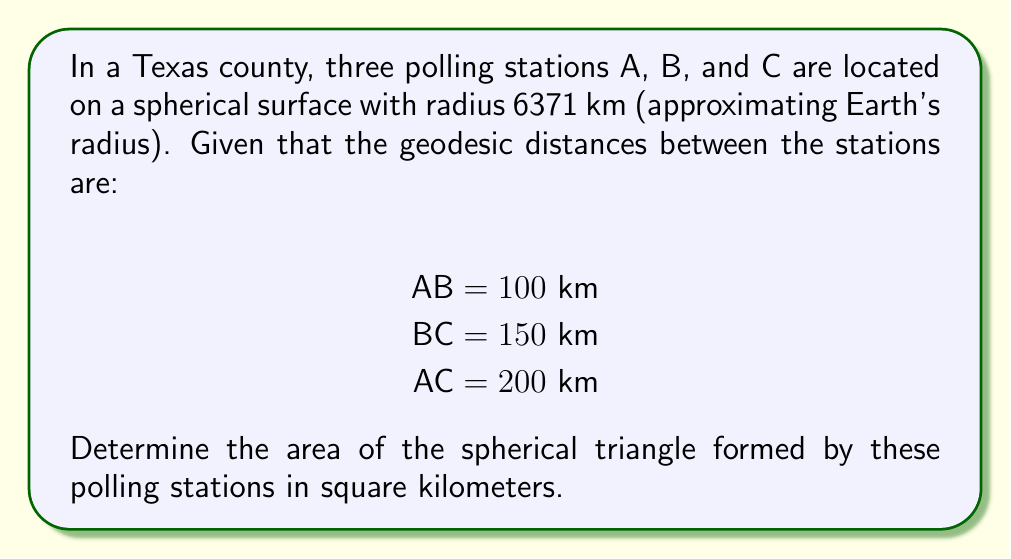Can you answer this question? To solve this problem, we'll use the spherical excess formula and follow these steps:

1. Convert the given distances to angles (in radians) using the arc length formula:
   $\theta = \frac{s}{r}$, where $s$ is the arc length and $r$ is the radius.

   $a = \frac{100}{6371} \approx 0.0157$ radians
   $b = \frac{150}{6371} \approx 0.0235$ radians
   $c = \frac{200}{6371} \approx 0.0314$ radians

2. Calculate the semi-perimeter $s$:
   $s = \frac{a + b + c}{2} \approx 0.0353$ radians

3. Use the spherical excess formula to calculate the excess $E$:
   $$\tan(\frac{E}{4}) = \sqrt{\tan(\frac{s}{2})\tan(\frac{s-a}{2})\tan(\frac{s-b}{2})\tan(\frac{s-c}{2})}$$

4. Solve for $E$:
   $E \approx 0.0000135$ radians

5. Calculate the area using the formula:
   $\text{Area} = E \cdot r^2$
   $\text{Area} = 0.0000135 \cdot 6371^2 \approx 548.17$ km²
Answer: 548.17 km² 